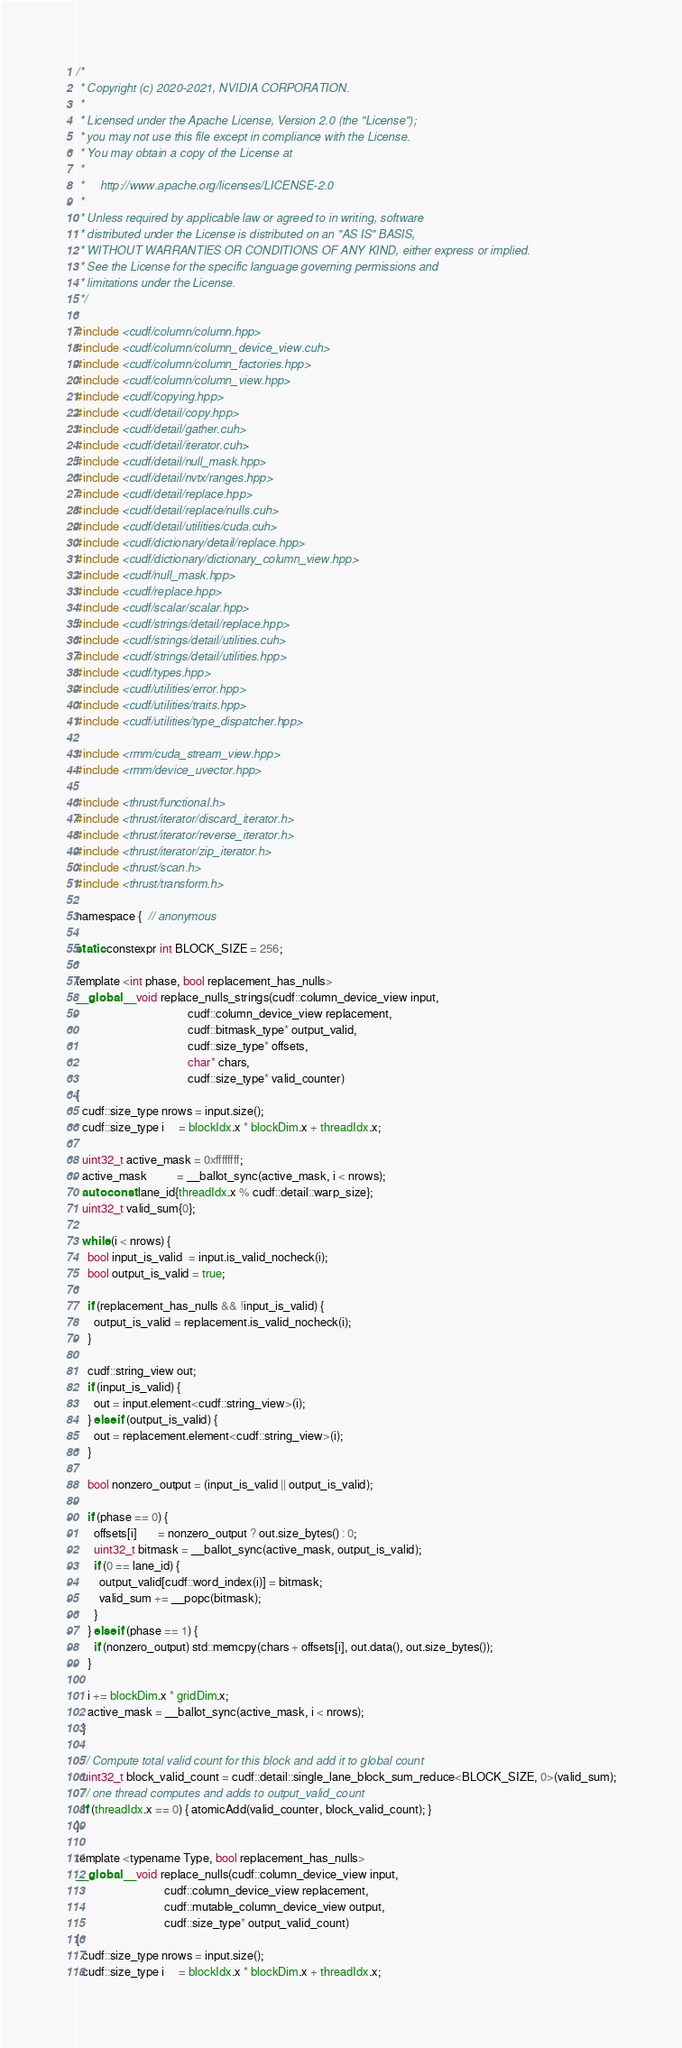<code> <loc_0><loc_0><loc_500><loc_500><_Cuda_>/*
 * Copyright (c) 2020-2021, NVIDIA CORPORATION.
 *
 * Licensed under the Apache License, Version 2.0 (the "License");
 * you may not use this file except in compliance with the License.
 * You may obtain a copy of the License at
 *
 *     http://www.apache.org/licenses/LICENSE-2.0
 *
 * Unless required by applicable law or agreed to in writing, software
 * distributed under the License is distributed on an "AS IS" BASIS,
 * WITHOUT WARRANTIES OR CONDITIONS OF ANY KIND, either express or implied.
 * See the License for the specific language governing permissions and
 * limitations under the License.
 */

#include <cudf/column/column.hpp>
#include <cudf/column/column_device_view.cuh>
#include <cudf/column/column_factories.hpp>
#include <cudf/column/column_view.hpp>
#include <cudf/copying.hpp>
#include <cudf/detail/copy.hpp>
#include <cudf/detail/gather.cuh>
#include <cudf/detail/iterator.cuh>
#include <cudf/detail/null_mask.hpp>
#include <cudf/detail/nvtx/ranges.hpp>
#include <cudf/detail/replace.hpp>
#include <cudf/detail/replace/nulls.cuh>
#include <cudf/detail/utilities/cuda.cuh>
#include <cudf/dictionary/detail/replace.hpp>
#include <cudf/dictionary/dictionary_column_view.hpp>
#include <cudf/null_mask.hpp>
#include <cudf/replace.hpp>
#include <cudf/scalar/scalar.hpp>
#include <cudf/strings/detail/replace.hpp>
#include <cudf/strings/detail/utilities.cuh>
#include <cudf/strings/detail/utilities.hpp>
#include <cudf/types.hpp>
#include <cudf/utilities/error.hpp>
#include <cudf/utilities/traits.hpp>
#include <cudf/utilities/type_dispatcher.hpp>

#include <rmm/cuda_stream_view.hpp>
#include <rmm/device_uvector.hpp>

#include <thrust/functional.h>
#include <thrust/iterator/discard_iterator.h>
#include <thrust/iterator/reverse_iterator.h>
#include <thrust/iterator/zip_iterator.h>
#include <thrust/scan.h>
#include <thrust/transform.h>

namespace {  // anonymous

static constexpr int BLOCK_SIZE = 256;

template <int phase, bool replacement_has_nulls>
__global__ void replace_nulls_strings(cudf::column_device_view input,
                                      cudf::column_device_view replacement,
                                      cudf::bitmask_type* output_valid,
                                      cudf::size_type* offsets,
                                      char* chars,
                                      cudf::size_type* valid_counter)
{
  cudf::size_type nrows = input.size();
  cudf::size_type i     = blockIdx.x * blockDim.x + threadIdx.x;

  uint32_t active_mask = 0xffffffff;
  active_mask          = __ballot_sync(active_mask, i < nrows);
  auto const lane_id{threadIdx.x % cudf::detail::warp_size};
  uint32_t valid_sum{0};

  while (i < nrows) {
    bool input_is_valid  = input.is_valid_nocheck(i);
    bool output_is_valid = true;

    if (replacement_has_nulls && !input_is_valid) {
      output_is_valid = replacement.is_valid_nocheck(i);
    }

    cudf::string_view out;
    if (input_is_valid) {
      out = input.element<cudf::string_view>(i);
    } else if (output_is_valid) {
      out = replacement.element<cudf::string_view>(i);
    }

    bool nonzero_output = (input_is_valid || output_is_valid);

    if (phase == 0) {
      offsets[i]       = nonzero_output ? out.size_bytes() : 0;
      uint32_t bitmask = __ballot_sync(active_mask, output_is_valid);
      if (0 == lane_id) {
        output_valid[cudf::word_index(i)] = bitmask;
        valid_sum += __popc(bitmask);
      }
    } else if (phase == 1) {
      if (nonzero_output) std::memcpy(chars + offsets[i], out.data(), out.size_bytes());
    }

    i += blockDim.x * gridDim.x;
    active_mask = __ballot_sync(active_mask, i < nrows);
  }

  // Compute total valid count for this block and add it to global count
  uint32_t block_valid_count = cudf::detail::single_lane_block_sum_reduce<BLOCK_SIZE, 0>(valid_sum);
  // one thread computes and adds to output_valid_count
  if (threadIdx.x == 0) { atomicAdd(valid_counter, block_valid_count); }
}

template <typename Type, bool replacement_has_nulls>
__global__ void replace_nulls(cudf::column_device_view input,
                              cudf::column_device_view replacement,
                              cudf::mutable_column_device_view output,
                              cudf::size_type* output_valid_count)
{
  cudf::size_type nrows = input.size();
  cudf::size_type i     = blockIdx.x * blockDim.x + threadIdx.x;
</code> 